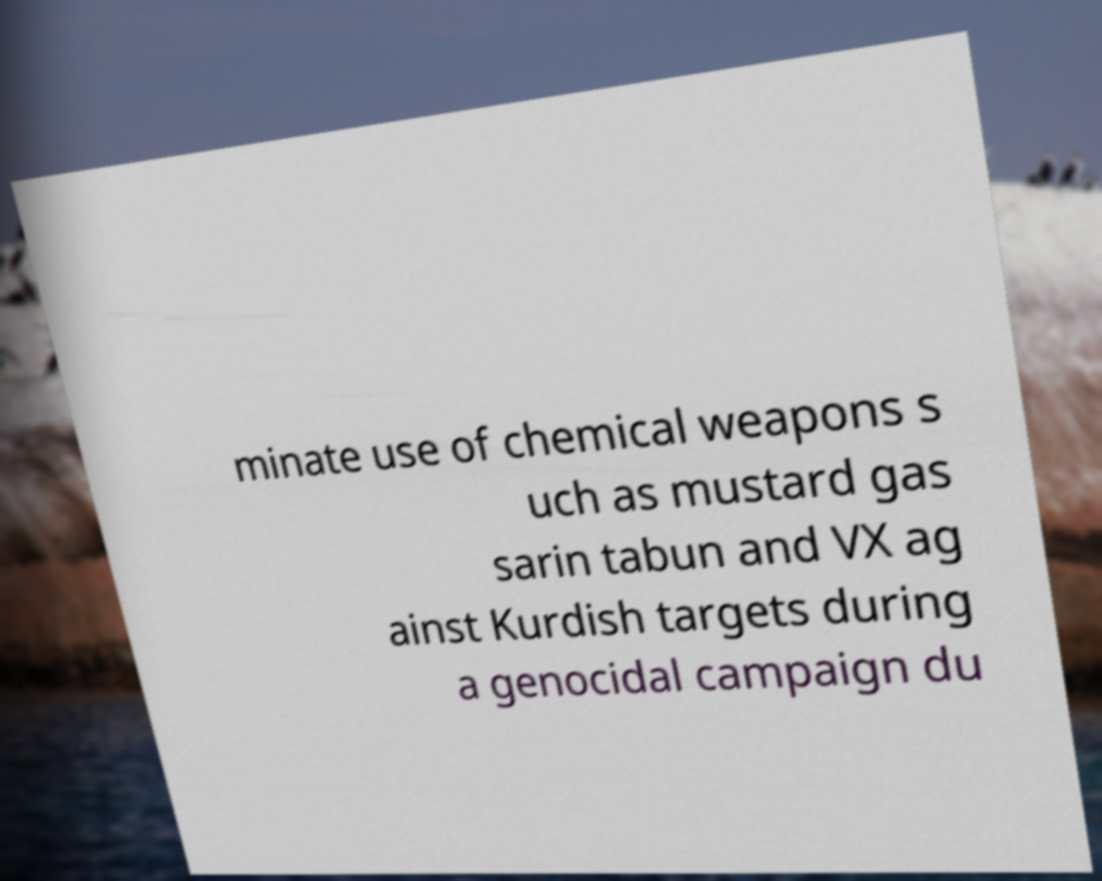For documentation purposes, I need the text within this image transcribed. Could you provide that? minate use of chemical weapons s uch as mustard gas sarin tabun and VX ag ainst Kurdish targets during a genocidal campaign du 